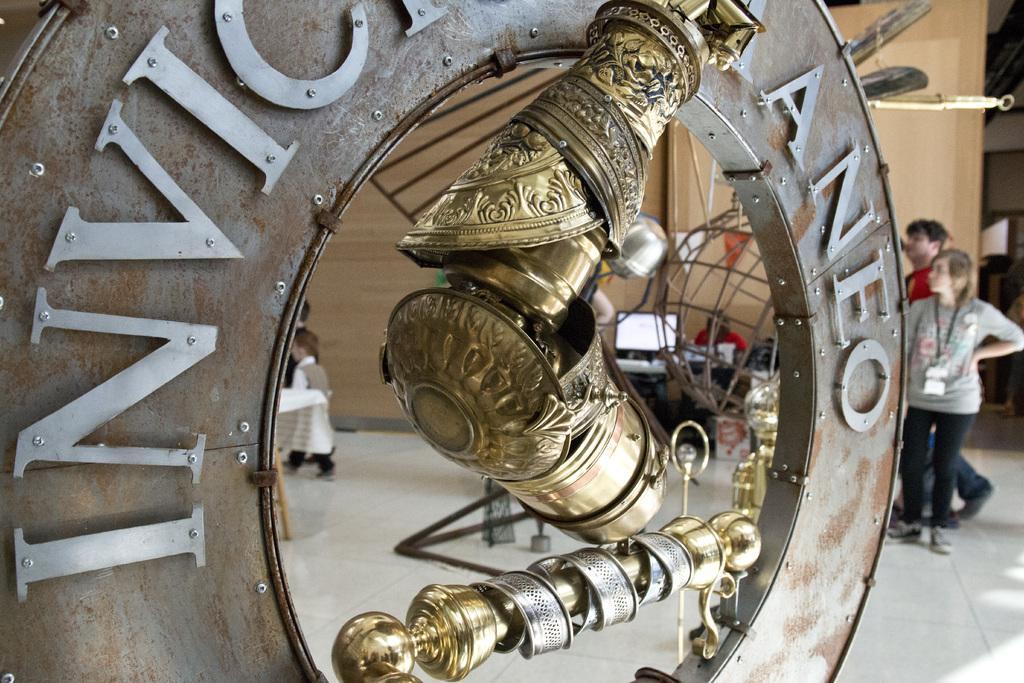Could you give a brief overview of what you see in this image? Front we can see metal objects. Something written on this metal ring. Background there is a wooden wall, people, tables, monitor, flags and board. 